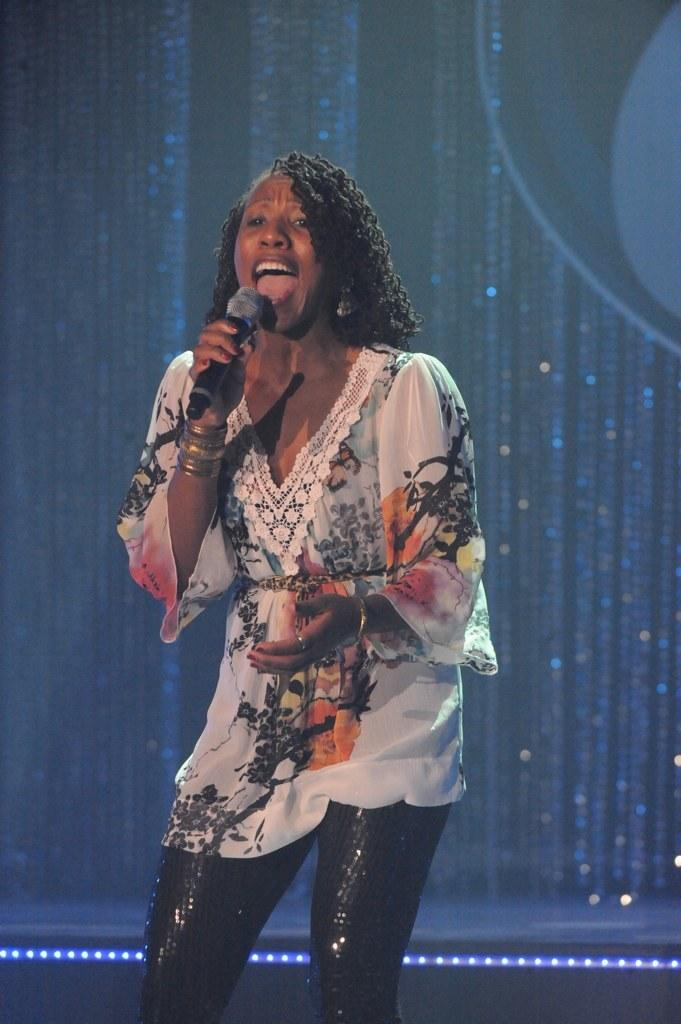Who is the main subject in the image? There is a woman in the image. What is the woman wearing? The woman is wearing a white dress and black trousers. What is the woman doing in the image? The woman is singing a song. What object is the woman holding in the image? The woman is holding a microphone. What color is the lighting in the background of the image? The lighting in the background of the image is blue. What type of lip balm is the woman applying in the image? There is no lip balm or any indication of the woman applying anything to her lips in the image. 